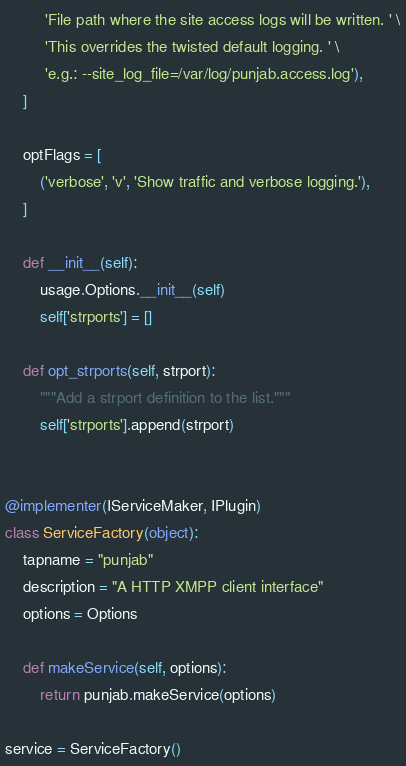<code> <loc_0><loc_0><loc_500><loc_500><_Python_>         'File path where the site access logs will be written. ' \
         'This overrides the twisted default logging. ' \
         'e.g.: --site_log_file=/var/log/punjab.access.log'),
    ]

    optFlags = [
        ('verbose', 'v', 'Show traffic and verbose logging.'),
    ]

    def __init__(self):
        usage.Options.__init__(self)
        self['strports'] = []

    def opt_strports(self, strport):
        """Add a strport definition to the list."""
        self['strports'].append(strport)


@implementer(IServiceMaker, IPlugin)
class ServiceFactory(object):
    tapname = "punjab"
    description = "A HTTP XMPP client interface"
    options = Options

    def makeService(self, options):
        return punjab.makeService(options)

service = ServiceFactory()

</code> 